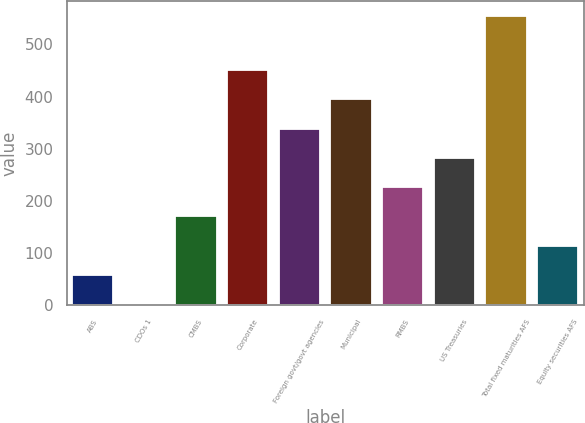Convert chart. <chart><loc_0><loc_0><loc_500><loc_500><bar_chart><fcel>ABS<fcel>CDOs 1<fcel>CMBS<fcel>Corporate<fcel>Foreign govt/govt agencies<fcel>Municipal<fcel>RMBS<fcel>US Treasuries<fcel>Total fixed maturities AFS<fcel>Equity securities AFS<nl><fcel>58.1<fcel>2<fcel>170.3<fcel>450.8<fcel>338.6<fcel>394.7<fcel>226.4<fcel>282.5<fcel>555<fcel>114.2<nl></chart> 